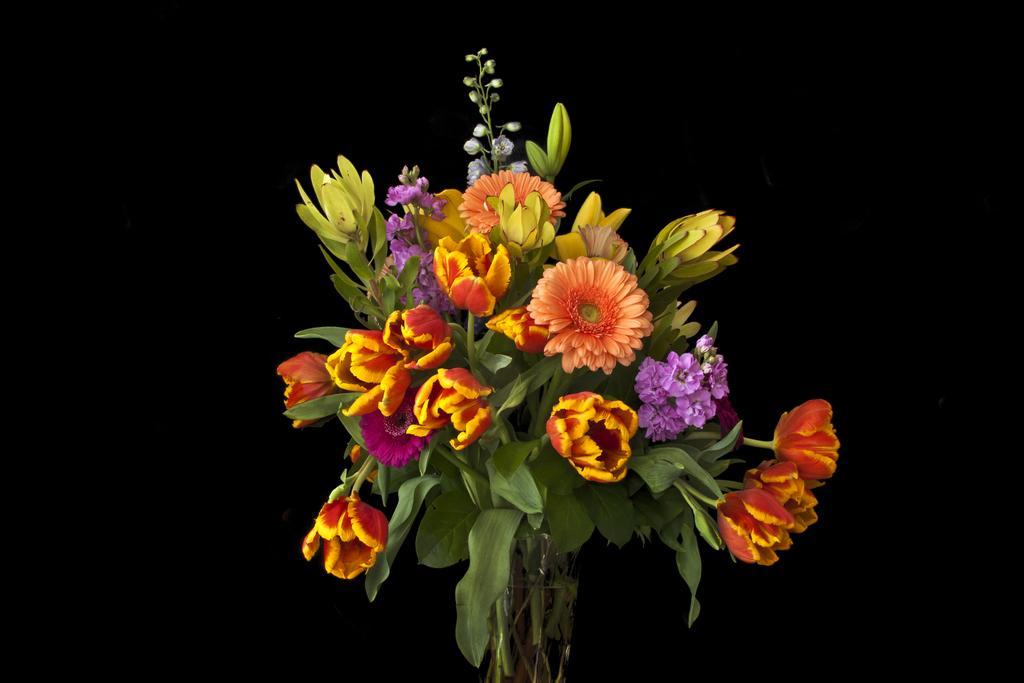How would you summarize this image in a sentence or two? In this image we can see vase with flowers and leaves on stems. In the background it is black. 